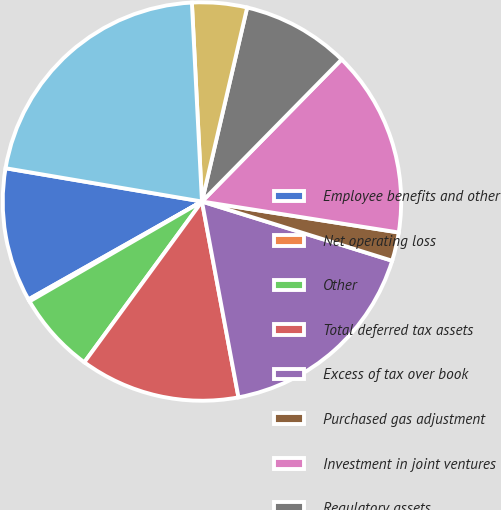<chart> <loc_0><loc_0><loc_500><loc_500><pie_chart><fcel>Employee benefits and other<fcel>Net operating loss<fcel>Other<fcel>Total deferred tax assets<fcel>Excess of tax over book<fcel>Purchased gas adjustment<fcel>Investment in joint ventures<fcel>Regulatory assets<fcel>Other comprehensive income<fcel>Total deferred tax liabilities<nl><fcel>10.85%<fcel>0.18%<fcel>6.59%<fcel>12.99%<fcel>17.26%<fcel>2.32%<fcel>15.12%<fcel>8.72%<fcel>4.45%<fcel>21.52%<nl></chart> 